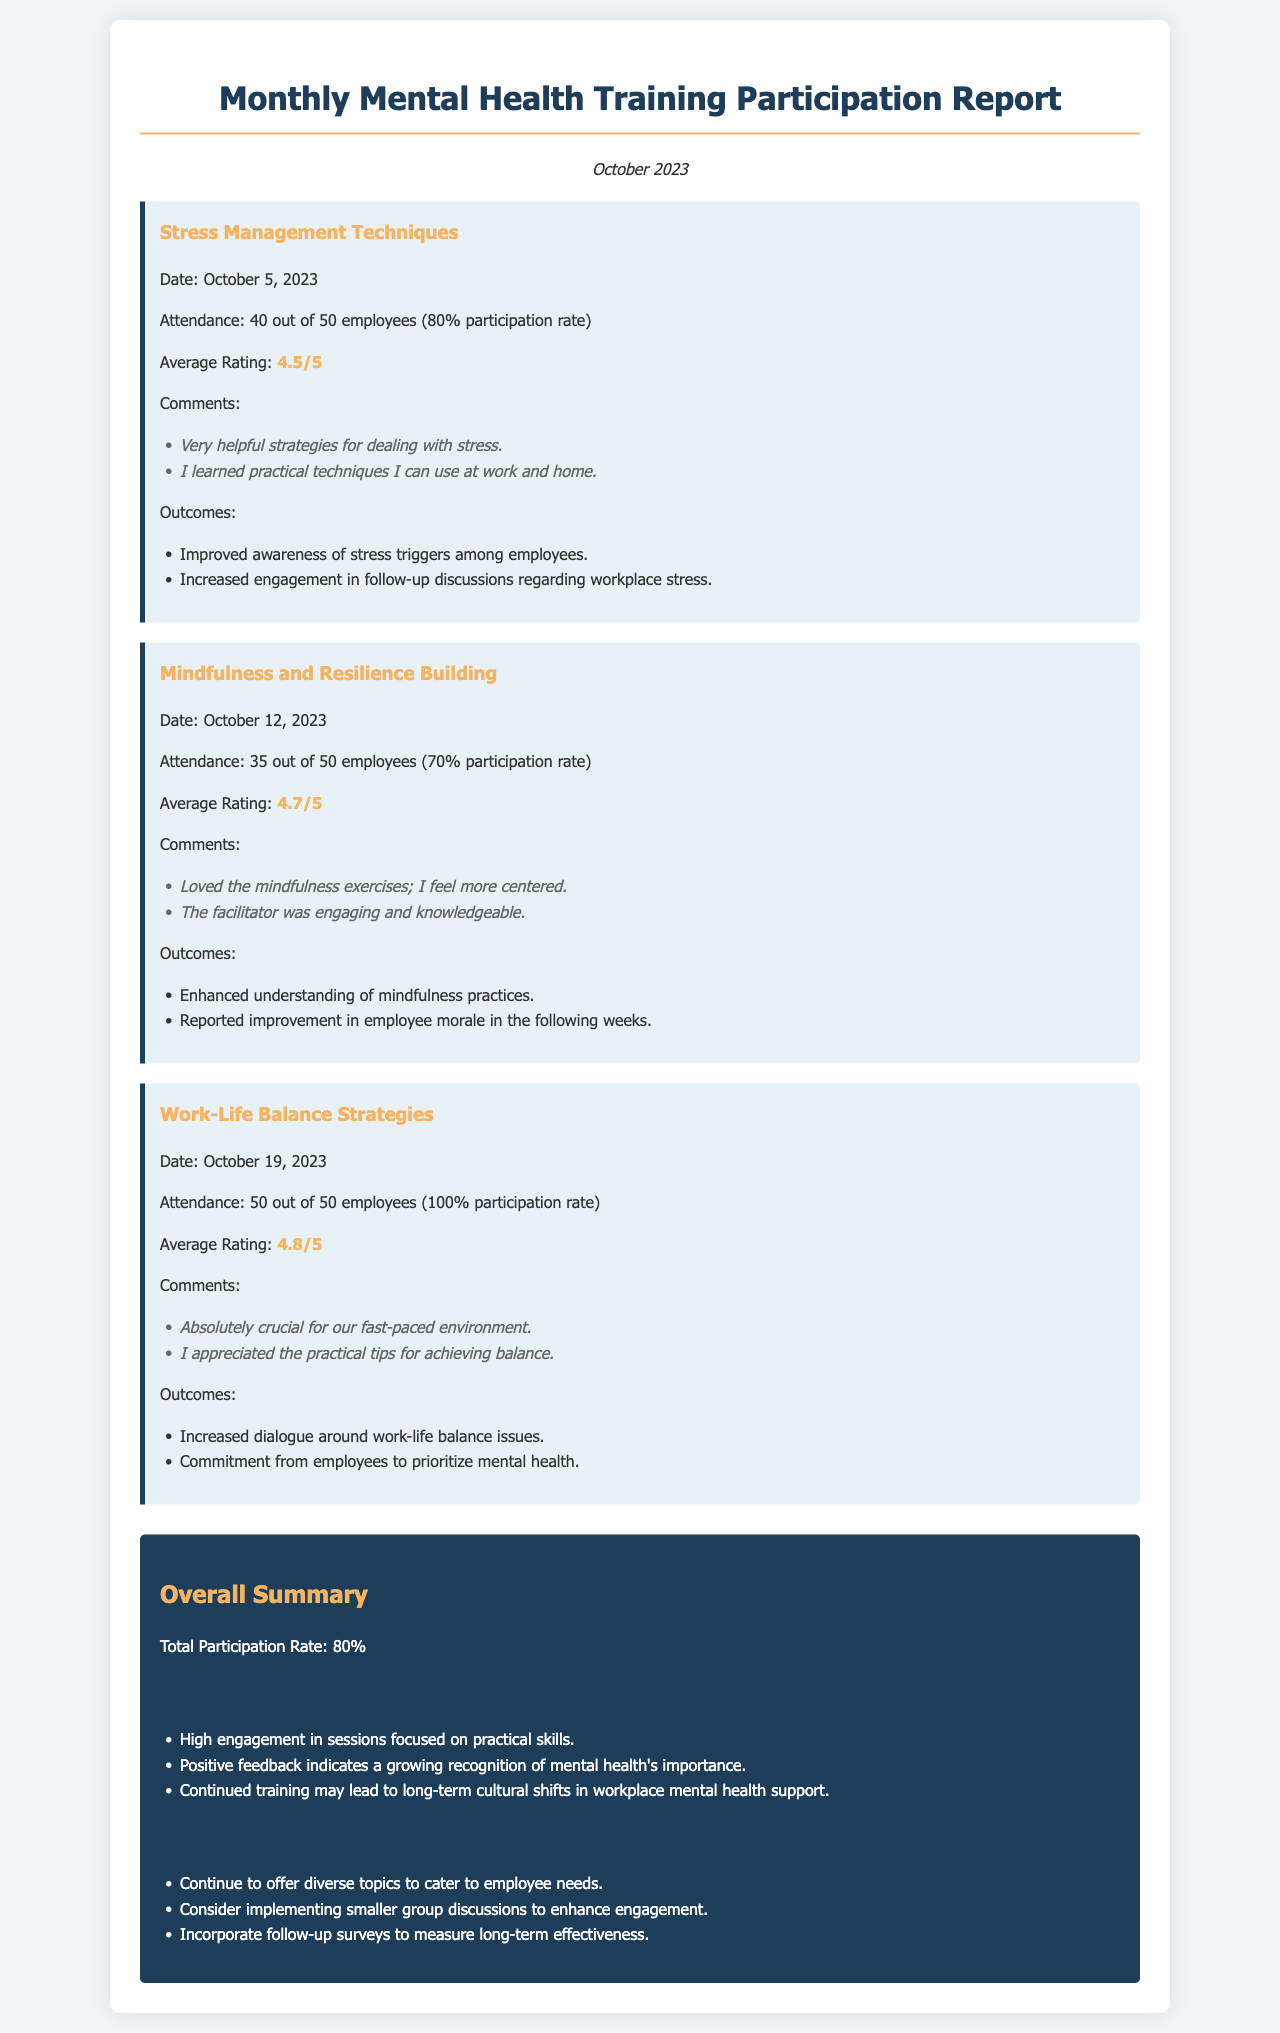What was the attendance for the Stress Management Techniques session? The attendance is stated as 40 out of 50 employees for the Stress Management Techniques session.
Answer: 40 out of 50 employees What is the average rating for the Work-Life Balance Strategies session? The average rating for the Work-Life Balance Strategies session is provided in the feedback section.
Answer: 4.8/5 What outcomes were noted from the Mindfulness and Resilience Building session? Outcomes are listed and include understanding mindfulness practices and improvement in morale.
Answer: Enhanced understanding of mindfulness practices, reported improvement in employee morale What was the total participation rate across all sessions? The total participation rate is included in the overall summary section of the document.
Answer: 80% How many days apart were the training sessions held? The training sessions' dates indicate they are held weekly, with one session per week.
Answer: 7 days apart What was a key insight noted in the overall summary? Key insights are summarized in a list, one of which is related to engagement with practical skills.
Answer: High engagement in sessions focused on practical skills What is one recommendation made in the report? Recommendations include various suggestions to enhance the training offerings, including better engagement strategies.
Answer: Continue to offer diverse topics to cater to employee needs When was the Mindfulness and Resilience Building session conducted? The date is explicitly mentioned for each session, including this one.
Answer: October 12, 2023 